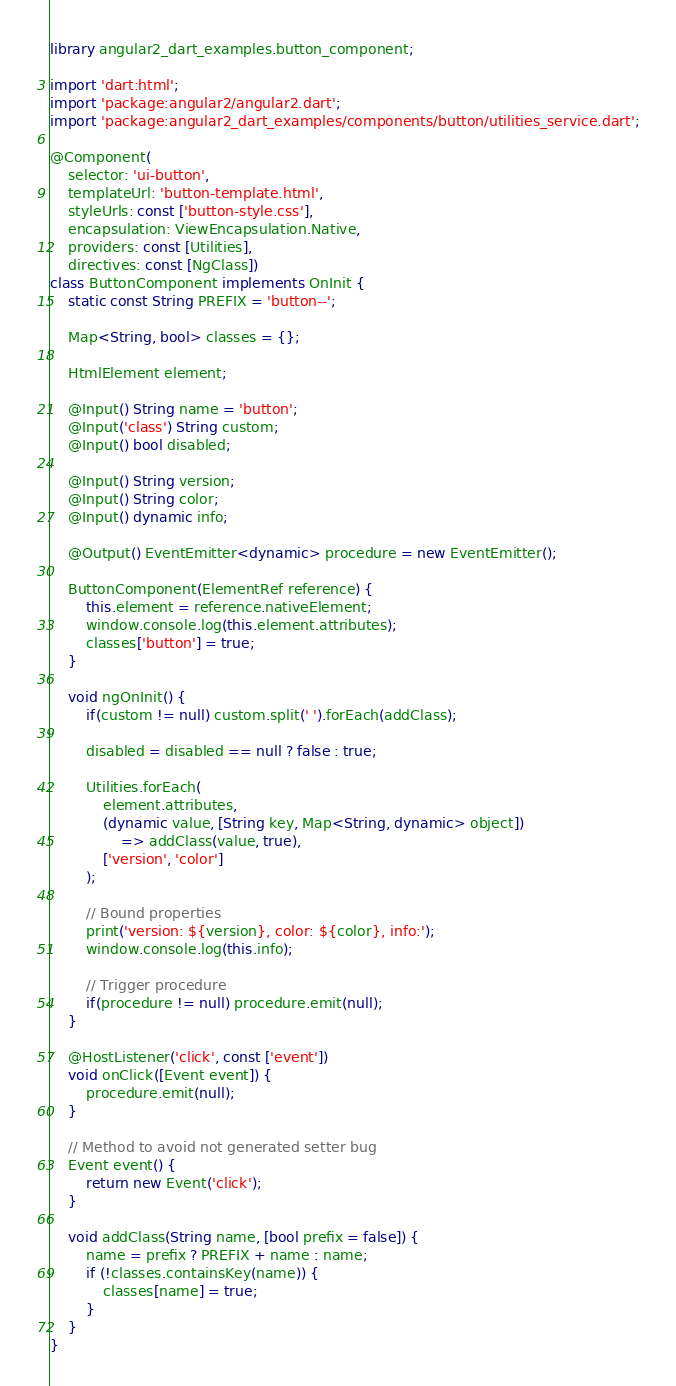Convert code to text. <code><loc_0><loc_0><loc_500><loc_500><_Dart_>library angular2_dart_examples.button_component;

import 'dart:html';
import 'package:angular2/angular2.dart';
import 'package:angular2_dart_examples/components/button/utilities_service.dart';

@Component(
	selector: 'ui-button',
	templateUrl: 'button-template.html',
	styleUrls: const ['button-style.css'],
	encapsulation: ViewEncapsulation.Native,
	providers: const [Utilities],
	directives: const [NgClass])
class ButtonComponent implements OnInit {
	static const String PREFIX = 'button--';

	Map<String, bool> classes = {};

	HtmlElement element;

	@Input() String name = 'button';
	@Input('class') String custom;
	@Input() bool disabled;
	
	@Input() String version;
	@Input() String color;
	@Input() dynamic info;

	@Output() EventEmitter<dynamic> procedure = new EventEmitter();

	ButtonComponent(ElementRef reference) {
		this.element = reference.nativeElement;
		window.console.log(this.element.attributes);
		classes['button'] = true;
	}

	void ngOnInit() {
		if(custom != null) custom.split(' ').forEach(addClass);
		
		disabled = disabled == null ? false : true;
		
		Utilities.forEach(
			element.attributes,
			(dynamic value, [String key, Map<String, dynamic> object])
				=> addClass(value, true),
			['version', 'color']
		);
		
		// Bound properties
		print('version: ${version}, color: ${color}, info:');
		window.console.log(this.info);
		
		// Trigger procedure
		if(procedure != null) procedure.emit(null);
	}

	@HostListener('click', const ['event'])
	void onClick([Event event]) {
		procedure.emit(null);
	}

	// Method to avoid not generated setter bug
	Event event() {
		return new Event('click');
	}

	void addClass(String name, [bool prefix = false]) {
		name = prefix ? PREFIX + name : name;
		if (!classes.containsKey(name)) {
			classes[name] = true;
		}
	}
}</code> 